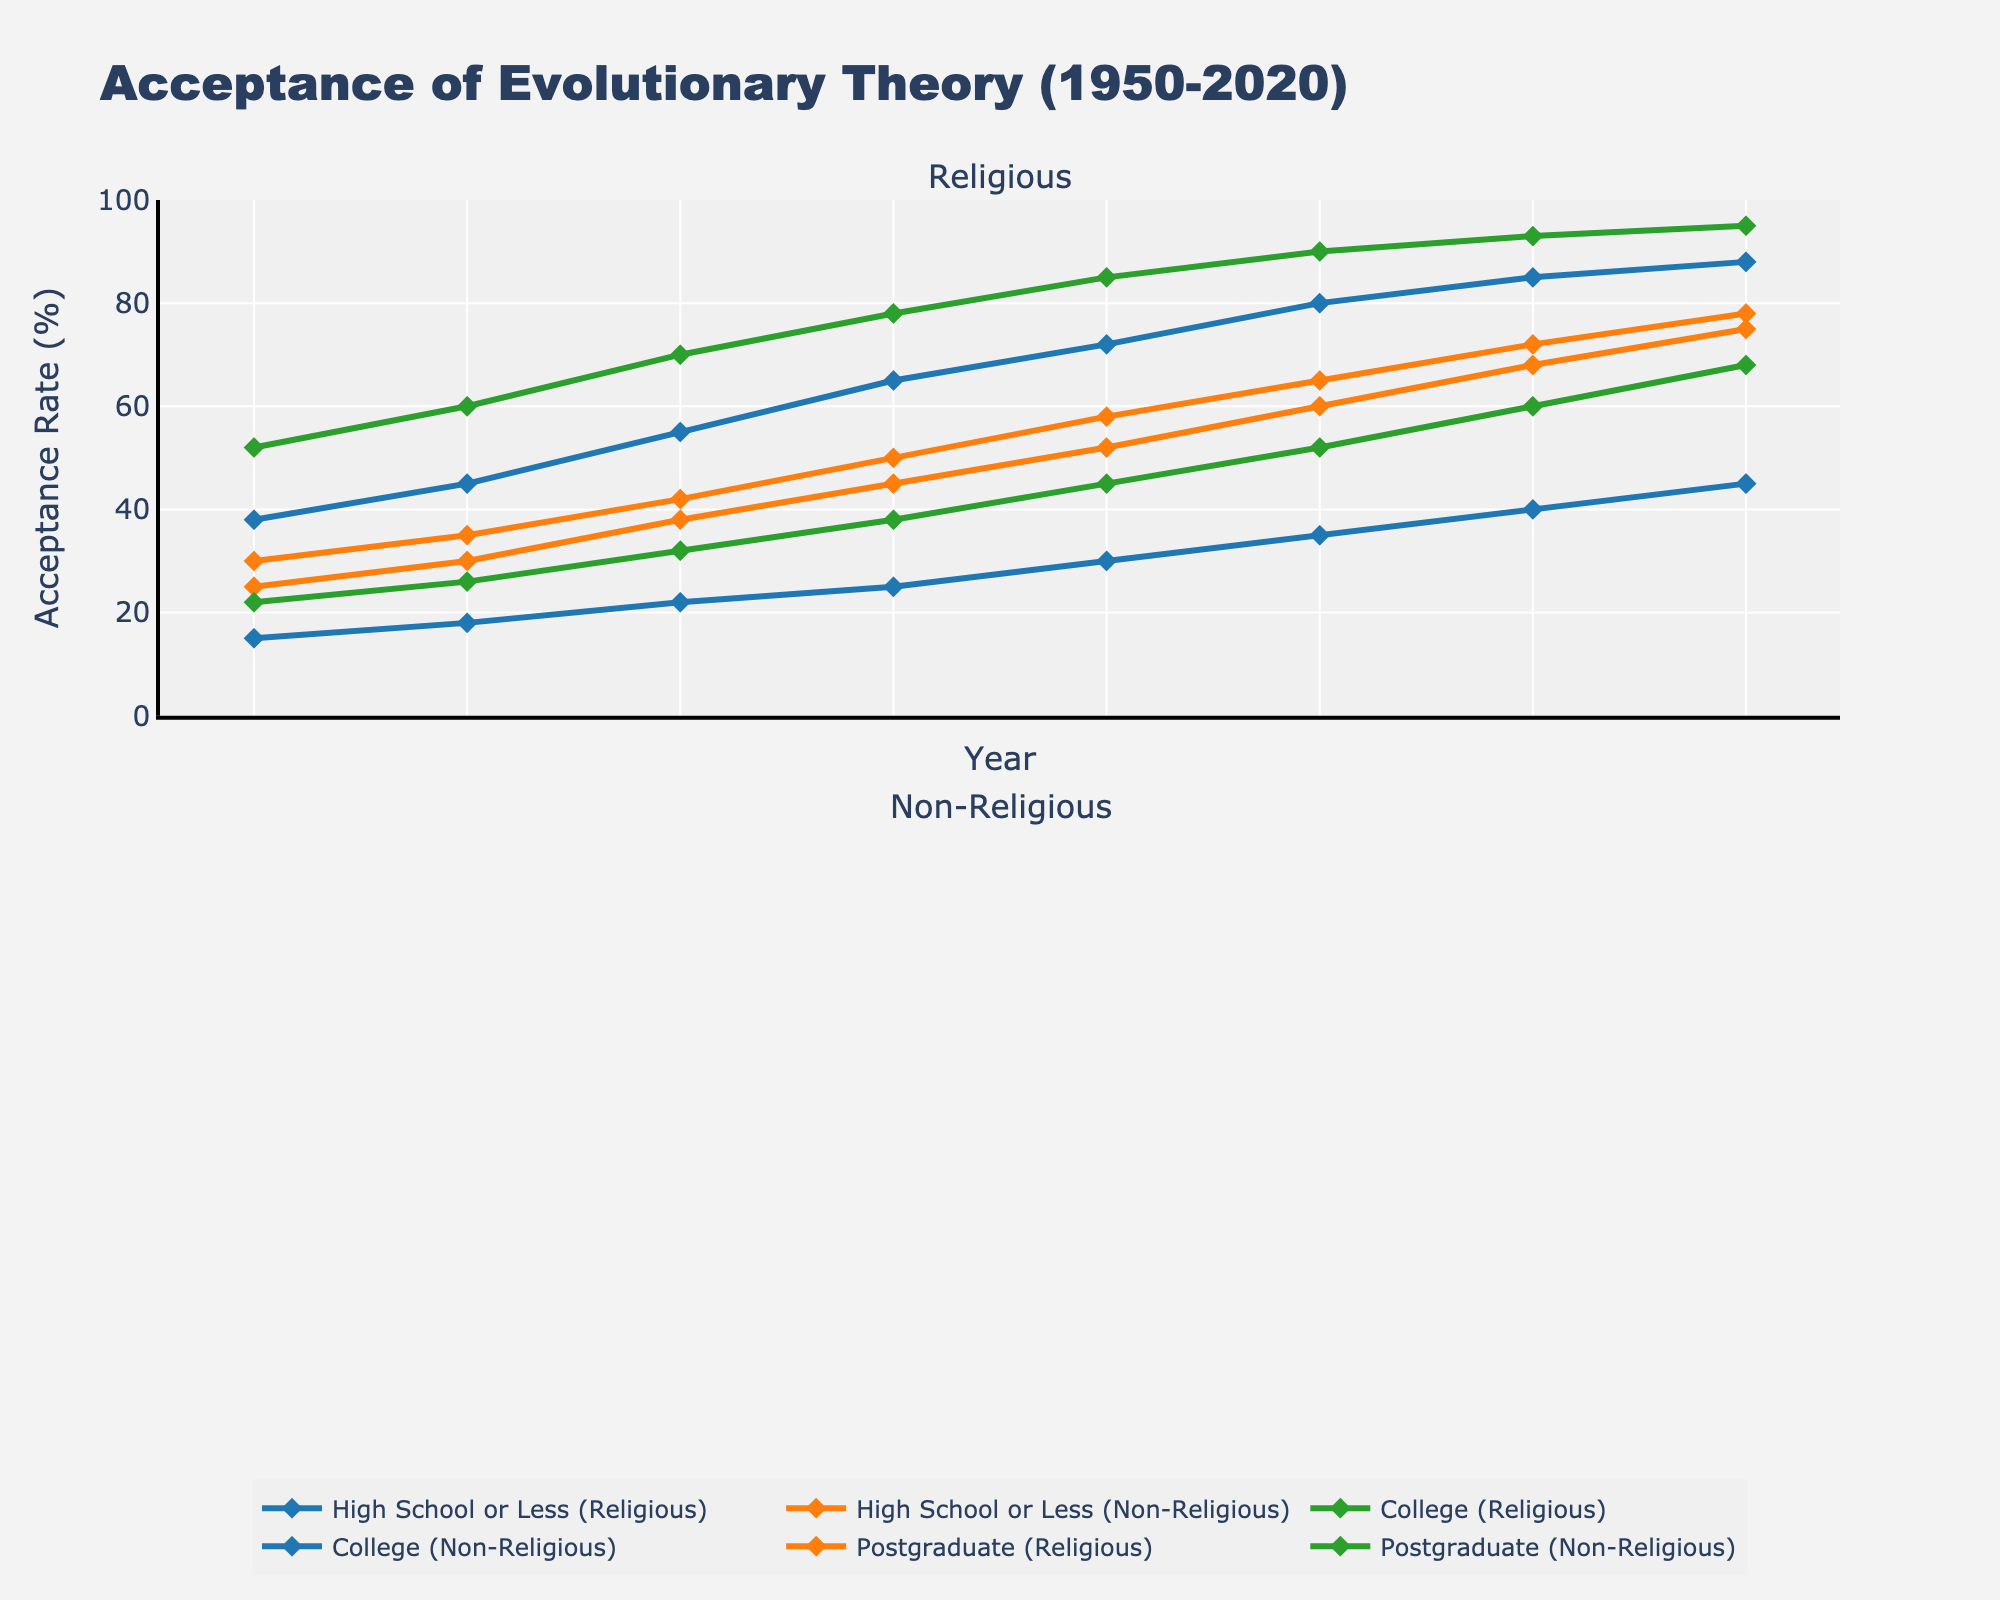Which group shows the highest acceptance rate of evolutionary theory in 2020? Look at the chart for the year 2020. The "Postgraduate (Non-Religious)" group has the highest point on the vertical axis.
Answer: Postgraduate (Non-Religious) How did the acceptance rate change for "High School or Less (Religious)" from 1950 to 2020? Observe the "High School or Less (Religious)" line from 1950 to 2020. The acceptance rate increased from 15% to 45%.
Answer: Increased by 30% Which educational and religious group has the lowest acceptance rate of evolutionary theory in 1950? Check the points for all groups in the year 1950. The "High School or Less (Religious)" group has the lowest acceptance rate at 15%.
Answer: High School or Less (Religious) What is the average acceptance rate of evolutionary theory for "College (Non-Religious)" between 1950 and 2020? Add the "College (Non-Religious)" values from each year and then divide by the number of years (8). (38+45+55+65+72+80+85+88)/8 = 65.5
Answer: 65.5% How does the acceptance rate of "College (Religious)" compare to "College (Non-Religious)" in 1980? Find the values for both groups in 1980. "College (Religious)" is at 38% and "College (Non-Religious)" is at 65%. 65% - 38% = 27%
Answer: College (Non-Religious) is 27% higher Which trend is more significant: the increase in acceptance rates for religious individuals or non-religious individuals over the entire period? Compare the line slopes for both groups over time. All educational levels show steeper slopes for non-religious individuals compared to religious ones.
Answer: Non-religious individuals What was the rate of increase in acceptance for "Postgraduate (Religious)" between 2000 and 2020? Calculate the change in acceptance for "Postgraduate (Religious)" from 2000 (65%) to 2020 (78%). 78% - 65% = 13%
Answer: Increased by 13% Between which periods did "High School or Less (Non-Religious)" see the largest increase in acceptance rate? Look for the steepest part of the "High School or Less (Non-Religious)" line. The largest increase is between 2000 (60%) and 2010 (68%).
Answer: 2000-2010 What is the difference in acceptance rates between "High School or Less (Religious)" and "Postgraduate (Religious)" in 1970? Subtract "High School or Less (Religious)" (22%) from "Postgraduate (Religious)" (42%) in 1970. 42% - 22% = 20%
Answer: 20% How does the acceptance trend of "Postgraduate (Religious)" compare to "College (Religious)" from 1950 to 2020? Observe both lines from 1950 to 2020. "Postgraduate (Religious)" started at 30% and ended at 78%, while "College (Religious)" started at 22% and ended at 68%, showing a steeper rise for the postgraduate group.
Answer: Postgraduate (Religious) has a steeper rise 